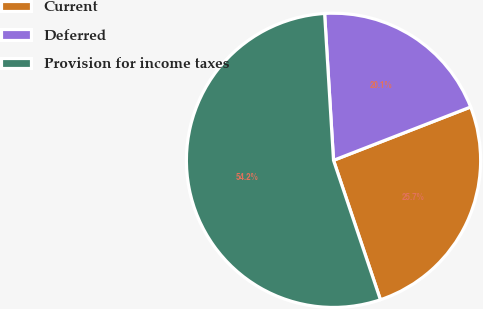Convert chart. <chart><loc_0><loc_0><loc_500><loc_500><pie_chart><fcel>Current<fcel>Deferred<fcel>Provision for income taxes<nl><fcel>25.74%<fcel>20.06%<fcel>54.2%<nl></chart> 